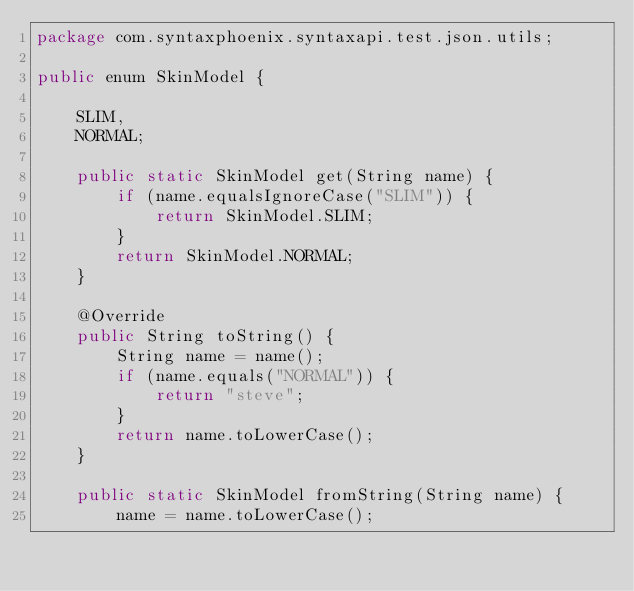<code> <loc_0><loc_0><loc_500><loc_500><_Java_>package com.syntaxphoenix.syntaxapi.test.json.utils;

public enum SkinModel {

    SLIM,
    NORMAL;

    public static SkinModel get(String name) {
        if (name.equalsIgnoreCase("SLIM")) {
            return SkinModel.SLIM;
        }
        return SkinModel.NORMAL;
    }

    @Override
    public String toString() {
        String name = name();
        if (name.equals("NORMAL")) {
            return "steve";
        }
        return name.toLowerCase();
    }

    public static SkinModel fromString(String name) {
        name = name.toLowerCase();</code> 